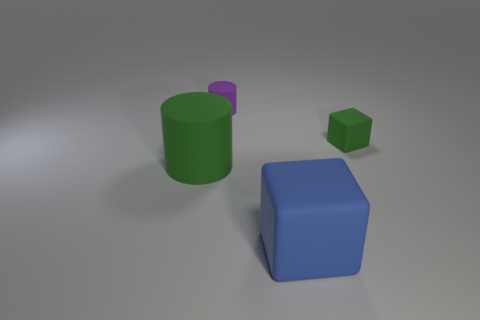Add 3 spheres. How many objects exist? 7 Subtract 0 cyan spheres. How many objects are left? 4 Subtract all tiny metallic things. Subtract all small green matte blocks. How many objects are left? 3 Add 3 cylinders. How many cylinders are left? 5 Add 4 large metallic cylinders. How many large metallic cylinders exist? 4 